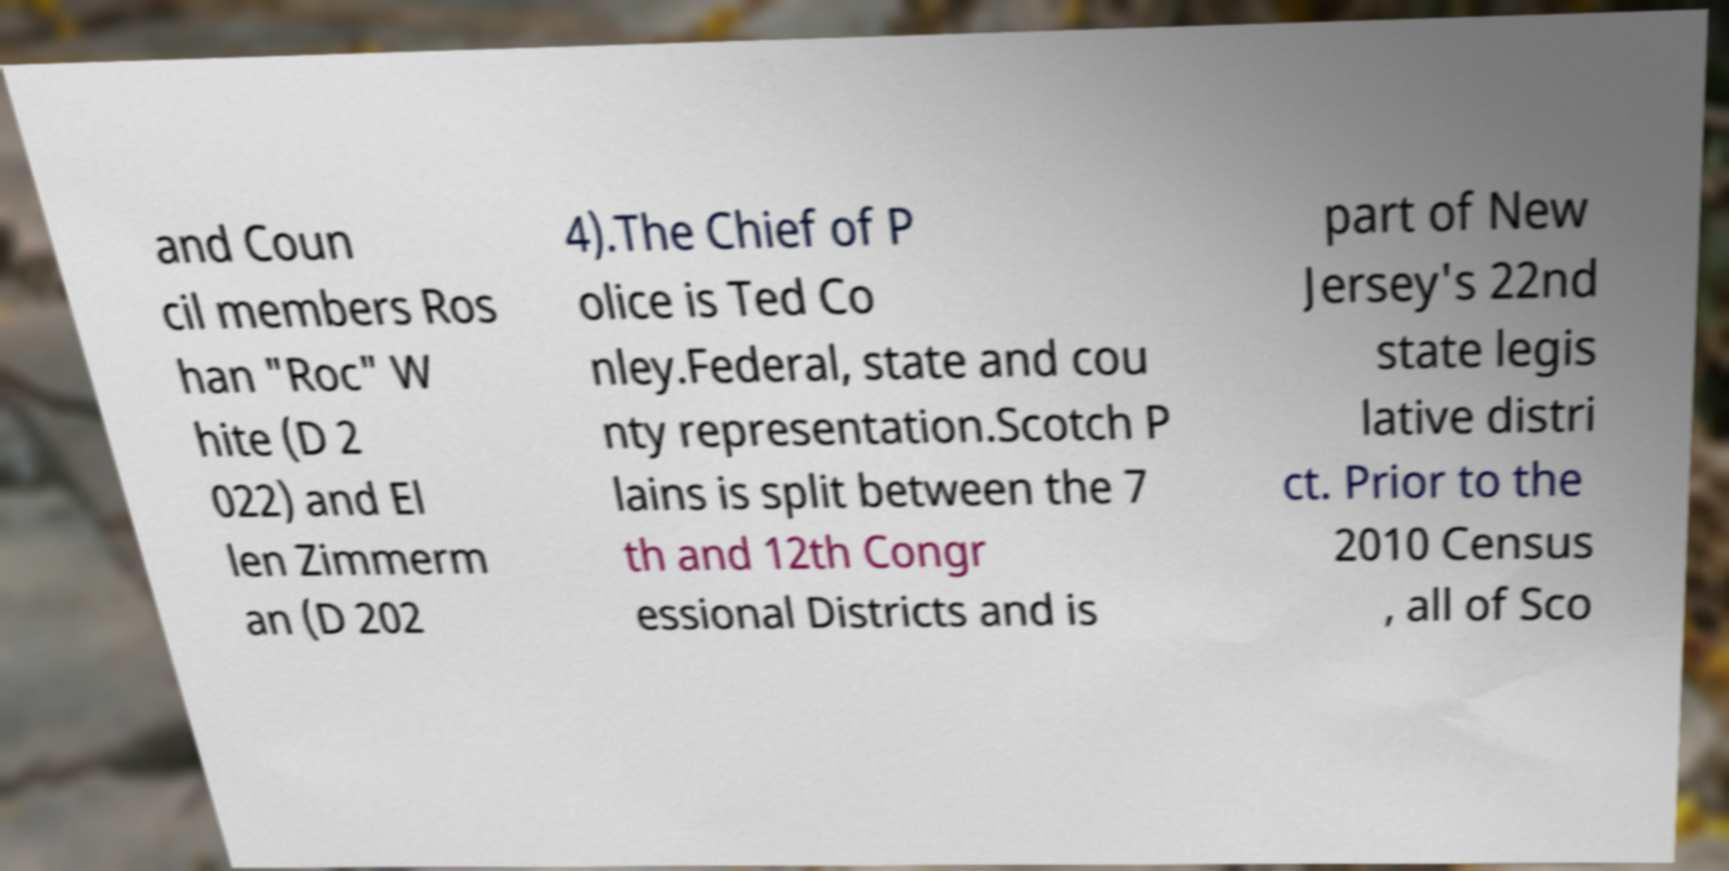I need the written content from this picture converted into text. Can you do that? and Coun cil members Ros han "Roc" W hite (D 2 022) and El len Zimmerm an (D 202 4).The Chief of P olice is Ted Co nley.Federal, state and cou nty representation.Scotch P lains is split between the 7 th and 12th Congr essional Districts and is part of New Jersey's 22nd state legis lative distri ct. Prior to the 2010 Census , all of Sco 